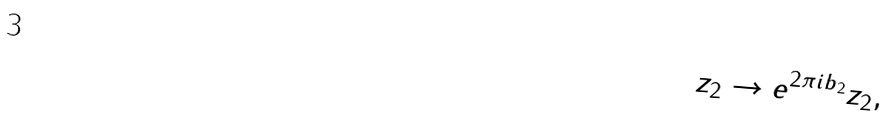Convert formula to latex. <formula><loc_0><loc_0><loc_500><loc_500>z _ { 2 } \rightarrow e ^ { 2 \pi i b _ { 2 } } z _ { 2 } , \,</formula> 